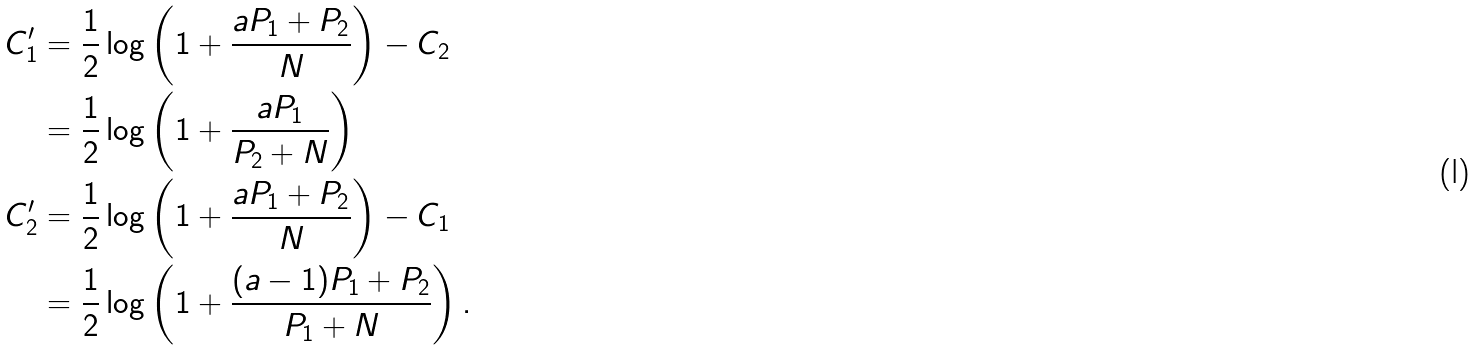<formula> <loc_0><loc_0><loc_500><loc_500>C ^ { \prime } _ { 1 } & = \frac { 1 } { 2 } \log \left ( 1 + \frac { a P _ { 1 } + P _ { 2 } } { N } \right ) - C _ { 2 } \\ & = \frac { 1 } { 2 } \log \left ( 1 + \frac { a P _ { 1 } } { P _ { 2 } + N } \right ) \\ C ^ { \prime } _ { 2 } & = \frac { 1 } { 2 } \log \left ( 1 + \frac { a P _ { 1 } + P _ { 2 } } { N } \right ) - C _ { 1 } \\ & = \frac { 1 } { 2 } \log \left ( 1 + \frac { ( a - 1 ) P _ { 1 } + P _ { 2 } } { P _ { 1 } + N } \right ) .</formula> 